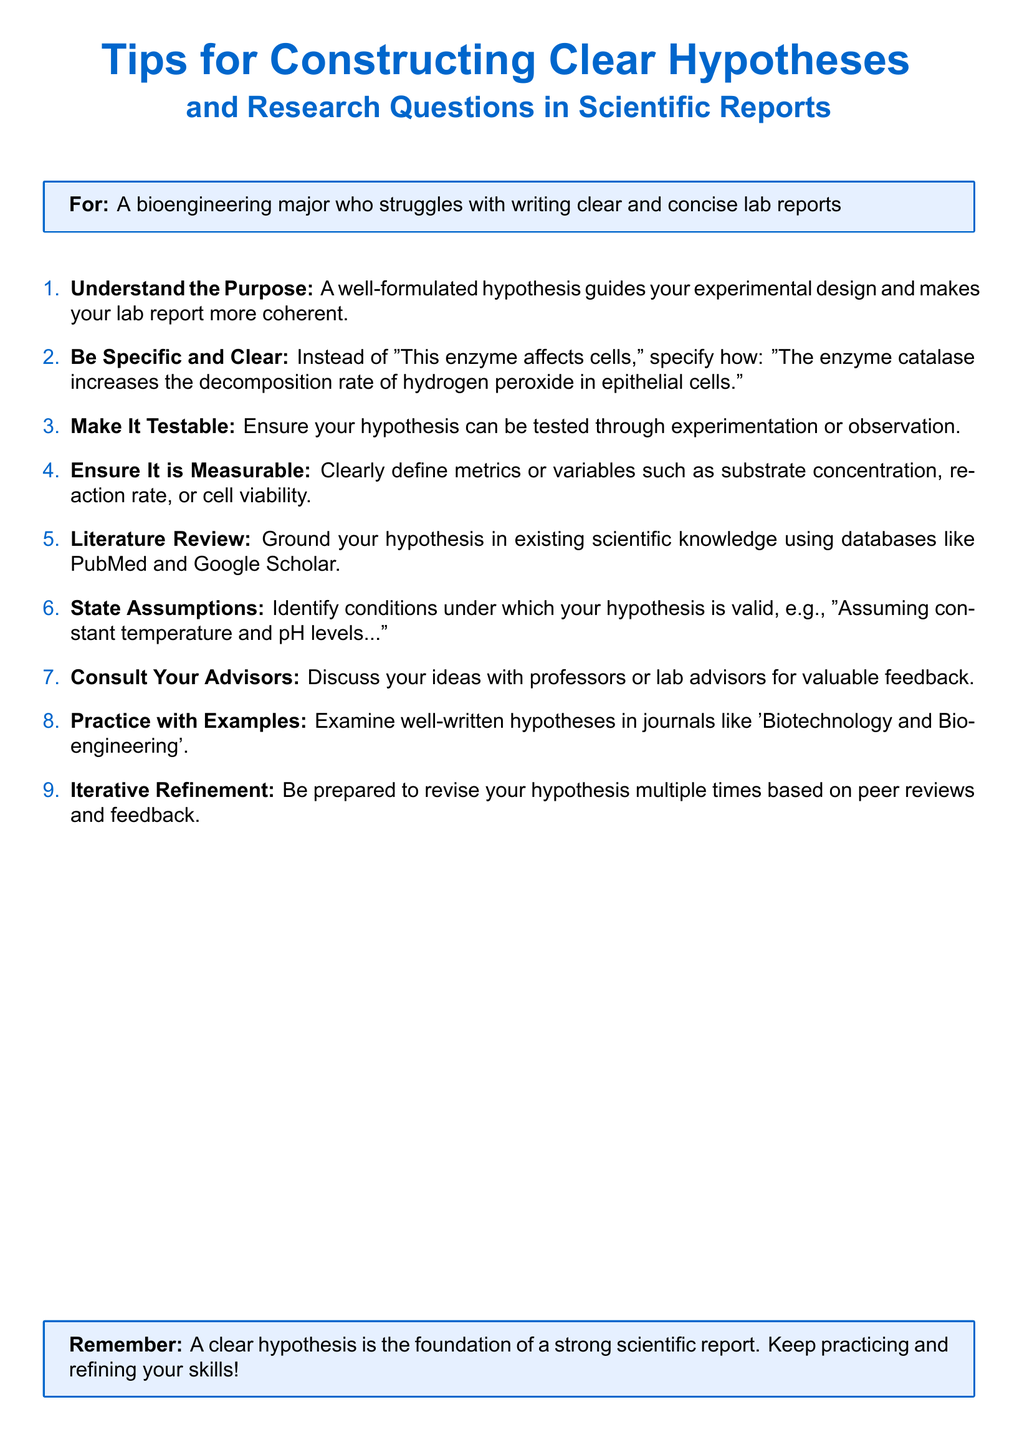What is the title of the document? The title is presented at the beginning of the document, which describes the content.
Answer: Tips for Constructing Clear Hypotheses and Research Questions in Scientific Reports Who is the document intended for? The intended audience is mentioned in a tcolorbox in the document.
Answer: A bioengineering major who struggles with writing clear and concise lab reports How many tips are provided in the document? The number of tips is stated by counting the enumerated items listed.
Answer: 9 What does the second tip emphasize? The content of the second tip focuses on clarity and specificity in hypotheses.
Answer: Be Specific and Clear According to the document, what is essential for a hypothesis besides being testable? This other quality is indicated in one of the tips that specify criteria for a good hypothesis.
Answer: Measurable What should you do to ground your hypothesis? The document suggests a specific action to support the foundation of your hypothesis.
Answer: Literature Review What is the last piece of advice given in the document? The last tip summarizes the importance of a repeating process for perfecting your hypothesis.
Answer: Iterative Refinement What should you assume when stating your hypothesis? This involves acknowledging certain conditions mentioned in the document to ensure validity.
Answer: Constant temperature and pH levels What type of publications does the document recommend reviewing for examples? The document suggests specific journals to look into for better understanding.
Answer: Biotechnology and Bioengineering 